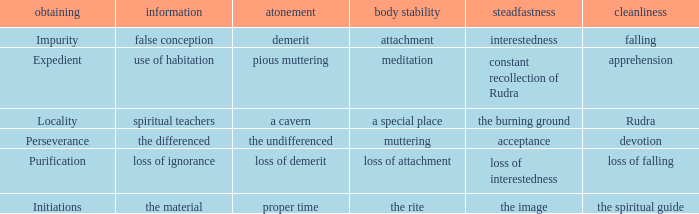 what's the permanence of the body where purity is rudra A special place. 